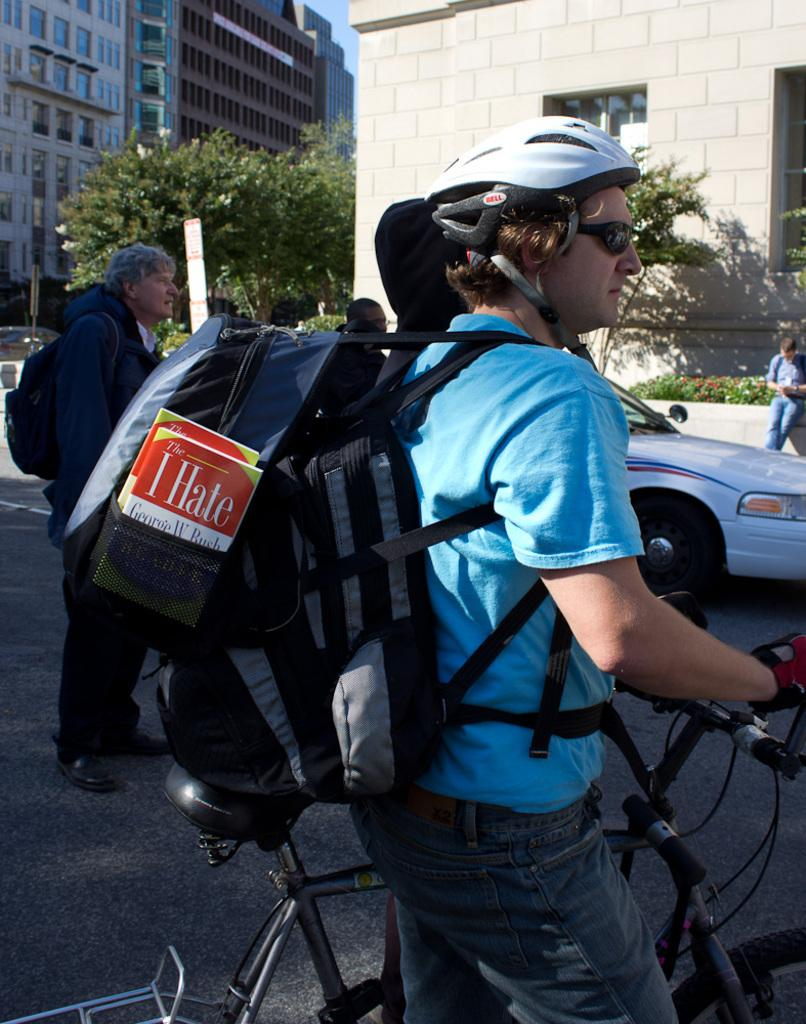<image>
Describe the image concisely. A man rides a bicycle with an I Hate book by George W. Bush in his backpack. 